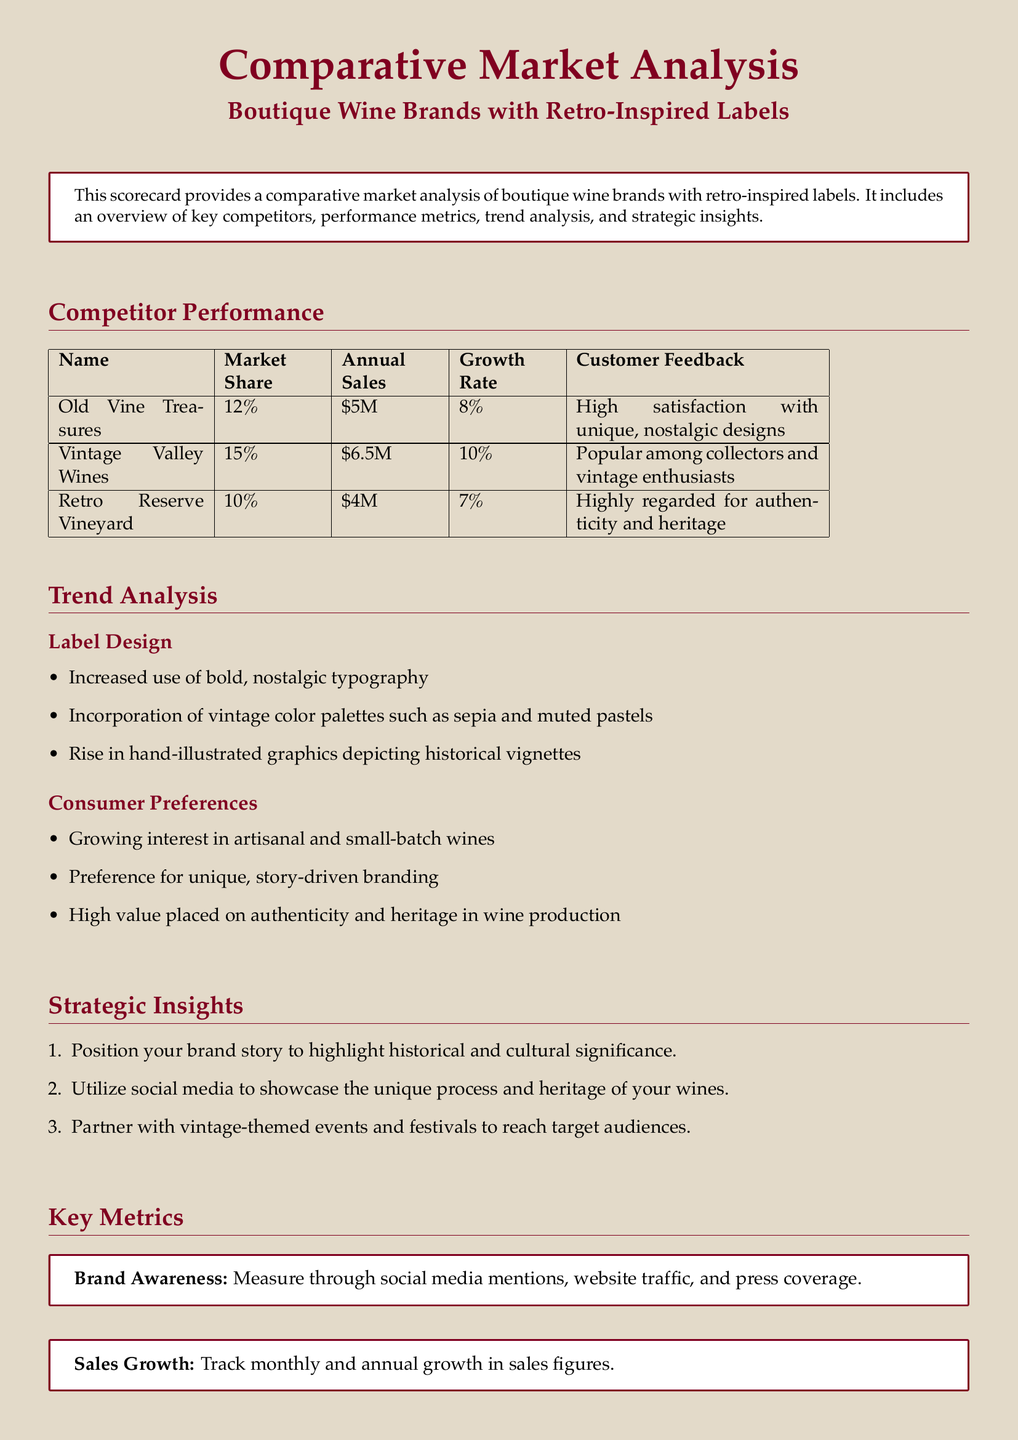What is the market share of Vintage Valley Wines? The market share of Vintage Valley Wines is provided in the Competitor Performance section of the document.
Answer: 15% What is the annual sales figure for Old Vine Treasures? The annual sales figure for Old Vine Treasures is listed in the Competitor Performance table.
Answer: $5M Which brand has the highest growth rate? To determine the brand with the highest growth rate, we compare the growth rates of all competitors in the document.
Answer: Vintage Valley Wines What is a key trend in label design? A key trend in label design is outlined in the Trend Analysis section, which reflects current industry movements.
Answer: Increased use of bold, nostalgic typography What metric is used to measure brand awareness? The document specifies how to measure brand awareness in the Key Metrics section, citing various methods.
Answer: Social media mentions, website traffic, and press coverage Which brand is highly regarded for authenticity and heritage? The Competitor Performance section provides insights into the reputation of each brand.
Answer: Retro Reserve Vineyard What is a recommended strategic action for marketing? The Strategic Insights section offers suggestions on how to effectively market a boutique wine brand with a retro theme.
Answer: Partner with vintage-themed events and festivals How is customer satisfaction gathered? The Key Metrics section describes methods of gathering customer feedback on satisfaction.
Answer: Surveys, reviews, and Net Promoter Scores What color palette is trending in label designs? The Trend Analysis section mentions specific color palettes as part of current design trends in the industry.
Answer: Vintage color palettes such as sepia and muted pastels 